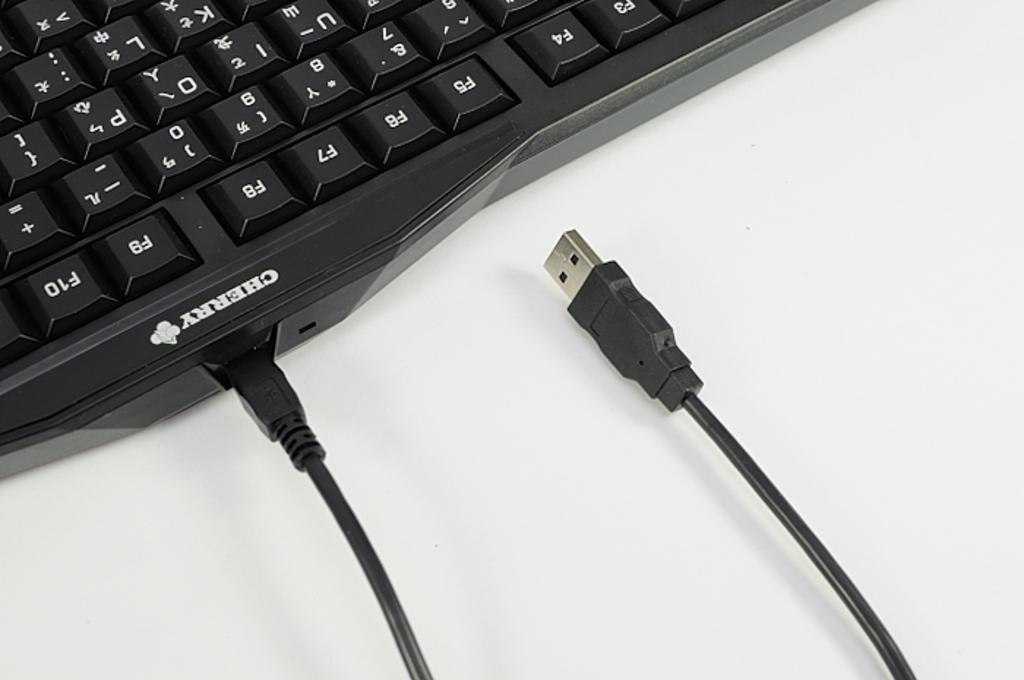<image>
Present a compact description of the photo's key features. a keyboard with many strange characters on it 